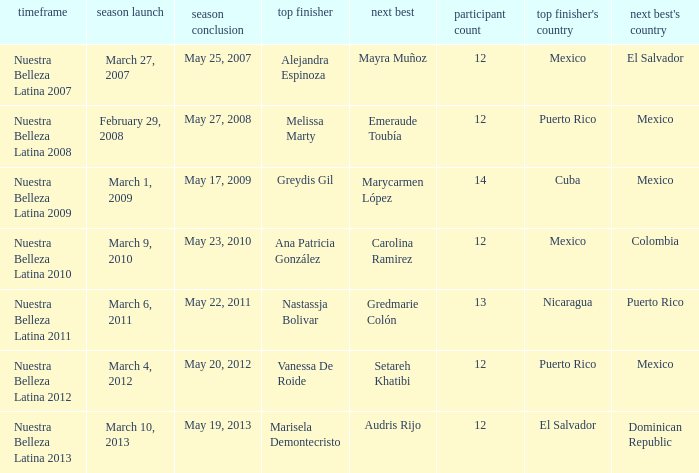What season's premiere had puerto rico winning on May 20, 2012? March 4, 2012. 